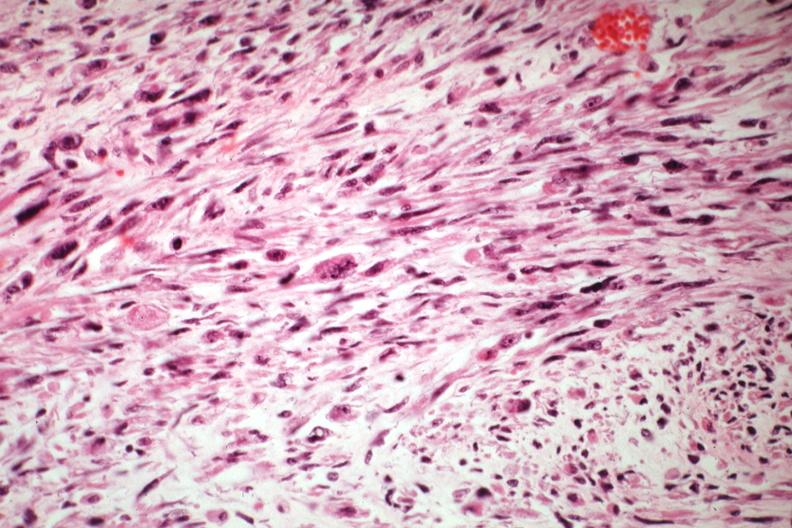where is this from?
Answer the question using a single word or phrase. Female reproductive system 